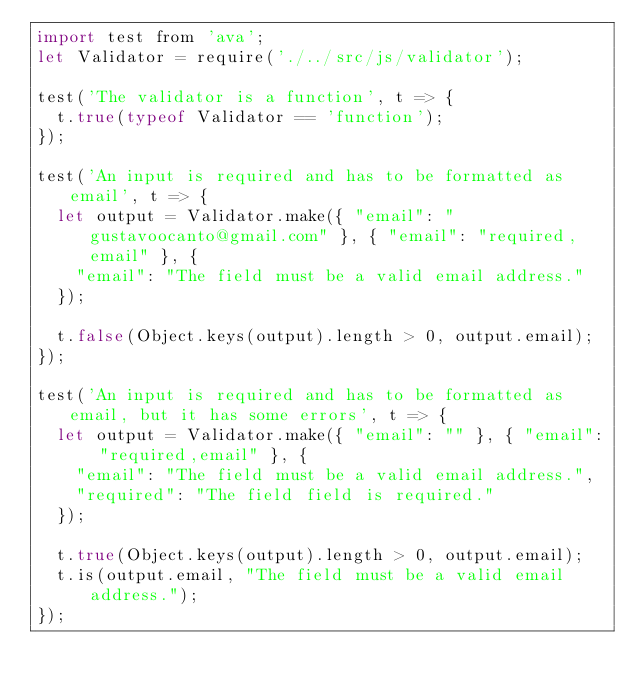<code> <loc_0><loc_0><loc_500><loc_500><_JavaScript_>import test from 'ava';
let Validator = require('./../src/js/validator');

test('The validator is a function', t => {
	t.true(typeof Validator == 'function');
});

test('An input is required and has to be formatted as email', t => {
	let output = Validator.make({ "email": "gustavoocanto@gmail.com" }, { "email": "required,email" }, {
		"email": "The field must be a valid email address."
	});

	t.false(Object.keys(output).length > 0, output.email);
});

test('An input is required and has to be formatted as email, but it has some errors', t => {
	let output = Validator.make({ "email": "" }, { "email": "required,email" }, {
		"email": "The field must be a valid email address.",
		"required": "The field field is required."
	});

	t.true(Object.keys(output).length > 0, output.email);
	t.is(output.email, "The field must be a valid email address.");
});

</code> 